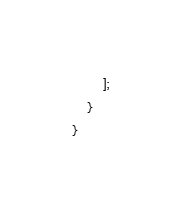<code> <loc_0><loc_0><loc_500><loc_500><_PHP_>        ];
    }
}
</code> 